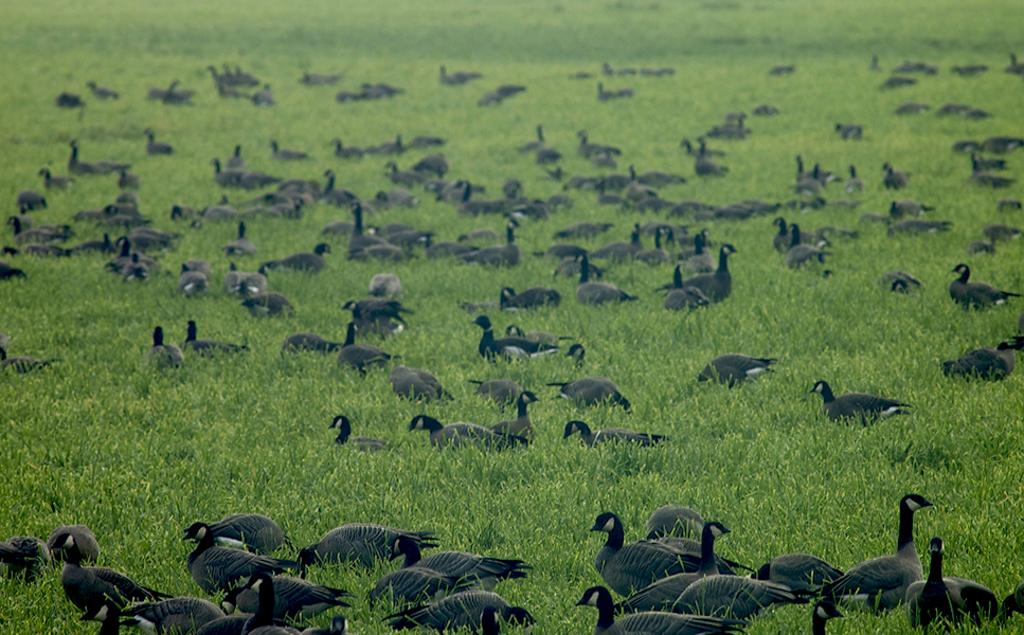What type of animals can be seen in the image? There is a group of birds in the image. What type of vegetation is visible in the image? There is grass visible in the image. What type of relation do the birds have with the winter season in the image? The image does not depict any relation between the birds and the winter season, as there is no mention of winter or any season in the provided facts. 